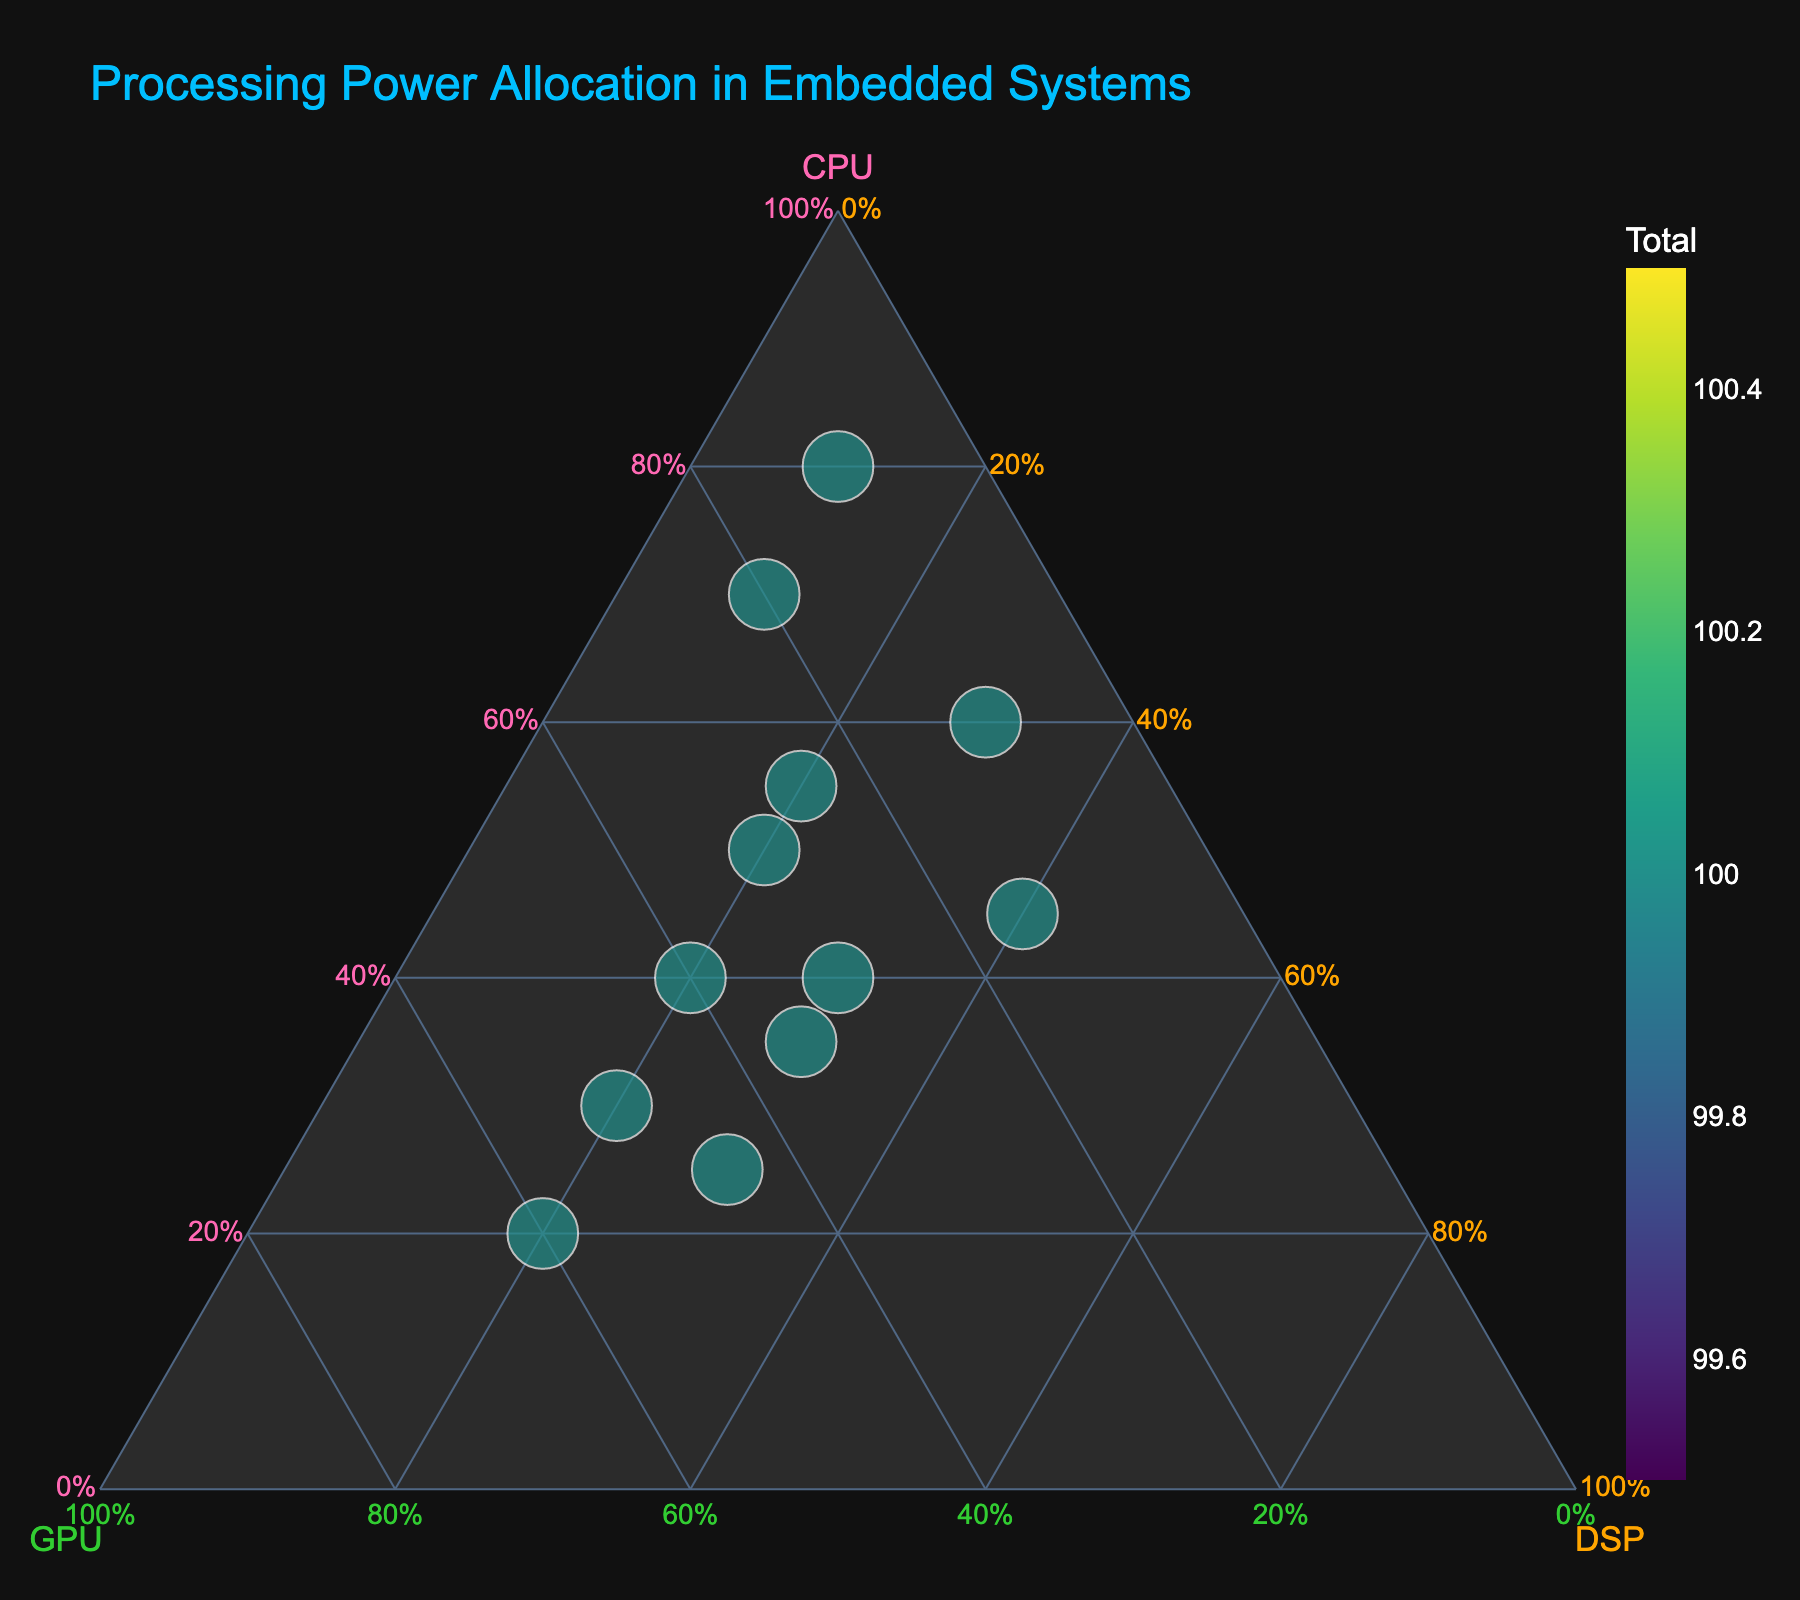What is the title of the plot? The title of the plot is displayed at the top and describes what the plot represents. In this case, it reads "Processing Power Allocation in Embedded Systems."
Answer: Processing Power Allocation in Embedded Systems Which project has the highest allocation to the CPU? Inspect the ternary plot and identify the data point closest to the CPU axis (a=1). The "Wearable Fitness Tracker" is near this axis, indicating it has the highest CPU allocation.
Answer: Wearable Fitness Tracker What proportion of DSP allocation does the "Smartphone Image Processing" project have? Find the point corresponding to "Smartphone Image Processing" and note the DSP value. The DSP allocation is 20%, as indicated along the DSP axis where this point aligns.
Answer: 20% Which project has the most balanced distribution between CPU, GPU, and DSP? Look for the point closest to the center of the plot, indicating similar allocations to CPU, GPU, and DSP. "Robotic Vision System" is closest to the center with 40% CPU, 30% GPU, and 30% DSP.
Answer: Robotic Vision System What are the normalized allocations for the "Gaming Console" project? Identify the point representing "Gaming Console" and note the values along CPU, GPU, and DSP axes. They are 30%, 50%, and 20%, respectively.
Answer: CPU: 30%, GPU: 50%, DSP: 20% Which project has the lowest GPU allocation? Find the data point closest to the DSP-CPU axis, far from the GPU axis. The "Industrial Control System" with 10% GPU allocation is the farthest from the GPU axis.
Answer: Industrial Control System How many projects have a DSP allocation greater than or equal to 30%? Identify the points with DSP values at or above 30% by looking at the DSP axis. The "Industrial Control System," "Voice Recognition Device," "Medical Imaging Equipment," "Drone Navigation System," and "Robotic Vision System" meet this criterion.
Answer: 5 If you sum the CPU allocations of "IoT Sensor Node" and "Smart Camera," what is the result? Locate both projects on the plot and sum their CPU values: 70% (IoT Sensor Node) + 55% (Smart Camera) = 125%.
Answer: 125% How does "Augmented Reality Headset" compare to "Gaming Console" in terms of GPU allocation? Find both points and compare their positions along the GPU axis. The "Augmented Reality Headset" (60%) has a higher GPU allocation compared to the "Gaming Console" (50%).
Answer: Augmented Reality Headset has a higher GPU allocation What's the proportion of CPU allocation for the project with the largest DSP allocation? Find the project with the highest DSP allocation, "Voice Recognition Device" (40%), and note its CPU allocation. This project has 45% CPU allocation.
Answer: 45% 